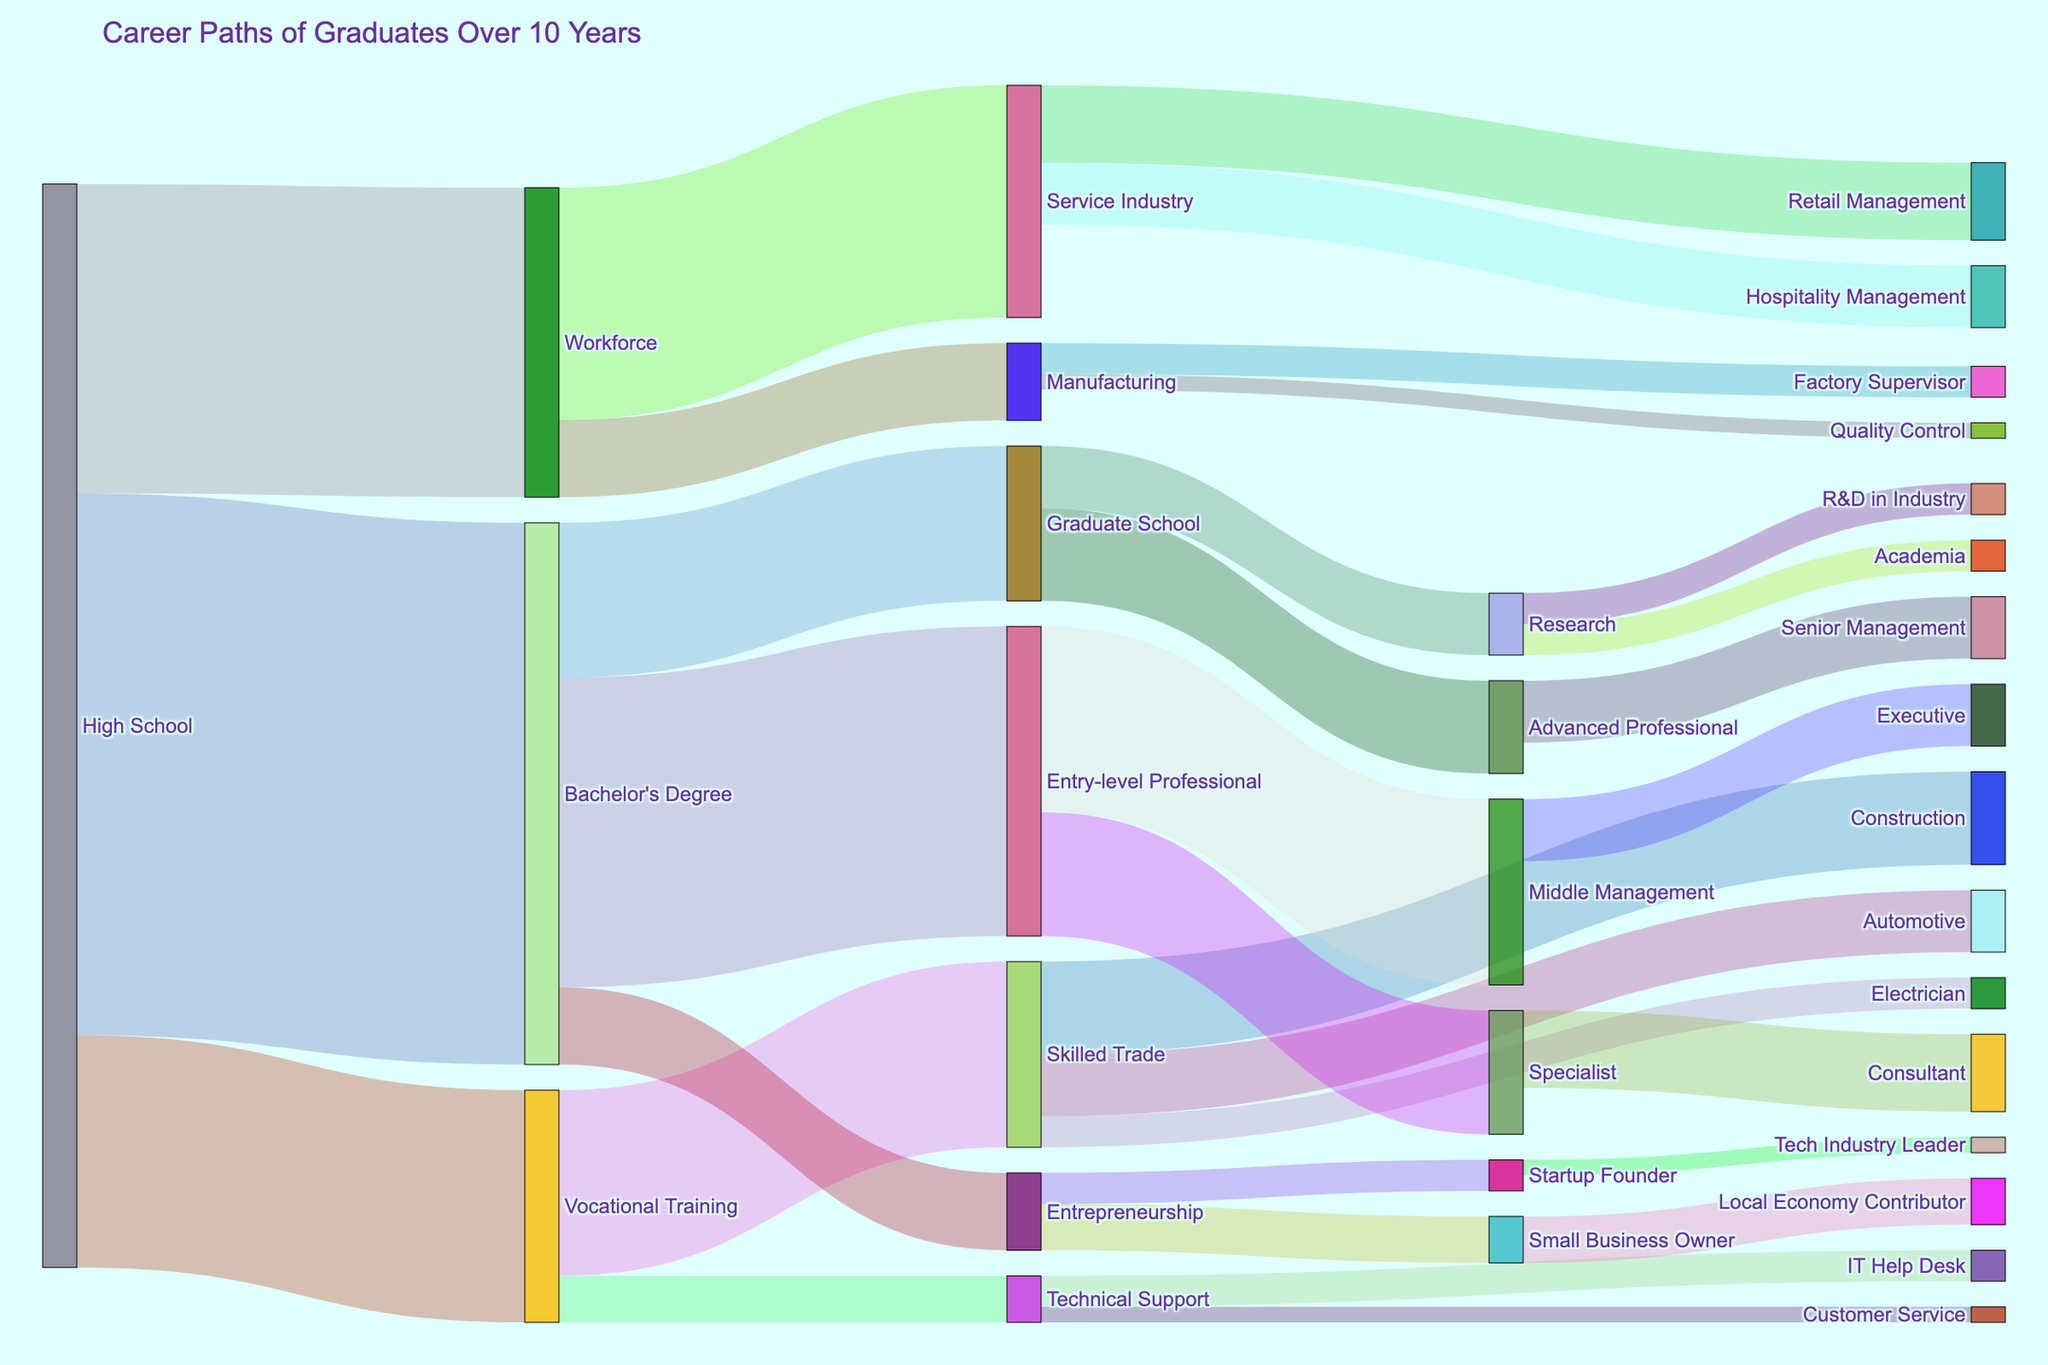what is the title of the figure? The title of the figure is usually displayed prominently at the top of the plot. By looking at the visual provided, we can directly read the title.
Answer: Career Paths of Graduates Over 10 Years How many graduates start with a High School education? Sum the values of all paths originating from "High School". We see paths to Vocational Training (1500), Bachelor's Degree (3500), and Workforce (2000). Summing these gives 1500 + 3500 + 2000.
Answer: 7000 Which career path receives the most Bachelor's Degree graduates? Check paths originating from "Bachelor's Degree". The values are Entry-level Professional (2000), Graduate School (1000), and Entrepreneurship (500). The highest value is 2000.
Answer: Entry-level Professional How many graduates move from Vocational Training to the Skilled Trade? This is a straightforward lookup. Find the value linking "Vocational Training" to "Skilled Trade" which is 1200.
Answer: 1200 Which path has the smallest number of graduates? Look for the smallest value in the figure. By observing the values, we see paths from Technical Support to Customer Service and Manufacturing to Quality Control both have the smallest value, which is 100.
Answer: Technical Support to Customer Service and Manufacturing to Quality Control What is the combined total of graduates who enter skilled trade from High School and Vocational Training? Sum the graduates moving from High School and Vocational Training to Skilled Trade. The paths are High School to Vocational Training to Skilled Trade 1500 (High School to Vocational Training) + 1200 (Vocational Training to Skilled Trade), which gives 1500 + 1200.
Answer: 2700 By how much does the number of Entry-level Professionals exceed the number of Advanced Professionals? Compare the values. Entry-level Professionals is 2000 and Advanced Professionals is 600. Subtract the value of Advanced Professionals from Entry-level Professionals, resulting in 2000 - 600.
Answer: 1400 What percentage of graduates with a Bachelor's Degree continue to Graduate School? Calculate the percentage by dividing the number of graduates moving to Graduate School by the total number of Bachelor's Degree holders. The path from Bachelor's Degree to Graduate School is 1000, total Bachelor's Degree holders are 3500. So, (1000/3500) * 100 which equals approximately 28.57%.
Answer: ~28.57% How many graduates enter the Service Industry from High School and Workforce? Add values of paths leading to the Service Industry. Service Industry paths: 1500 from Workforce, 0 direct from High School (as there is no direct path). Summing gives 1500 + 0.
Answer: 1500 What is the next career progression for Entry-level Professionals with the highest transfer rate? Observe the path from Entry-level Professional and see which has the highest value. The options are Middle Management (1200) and Specialist (800); the highest value is 1200.
Answer: Middle Management 